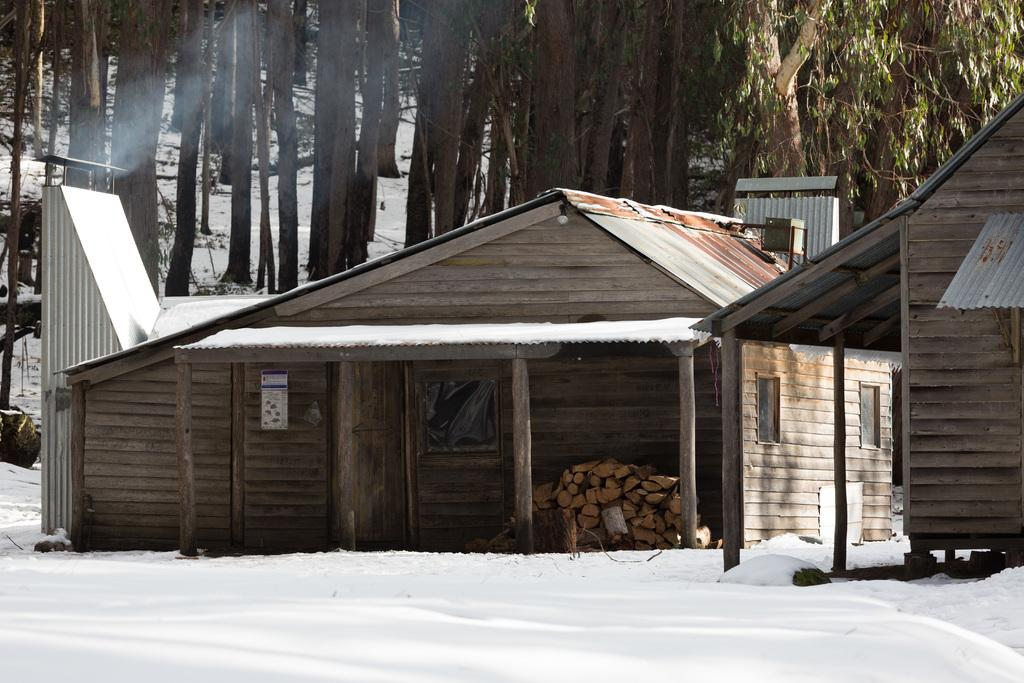What is the primary feature of the image's landscape? The image shows a snowy surface. What structures are present on the snowy surface? There are two wooden houses on the snowy surface. What architectural detail can be observed in the wooden houses? The wooden houses have pillars. What type of vegetation is visible in the background of the image? There are trees visible behind the wooden houses. What type of plantation can be seen behind the wooden houses in the image? There is no plantation visible in the image; only trees are present in the background. Can you tell me how many pencils are lying on the snowy surface in the image? There are no pencils present in the image; the focus is on the wooden houses and the snowy surface. 